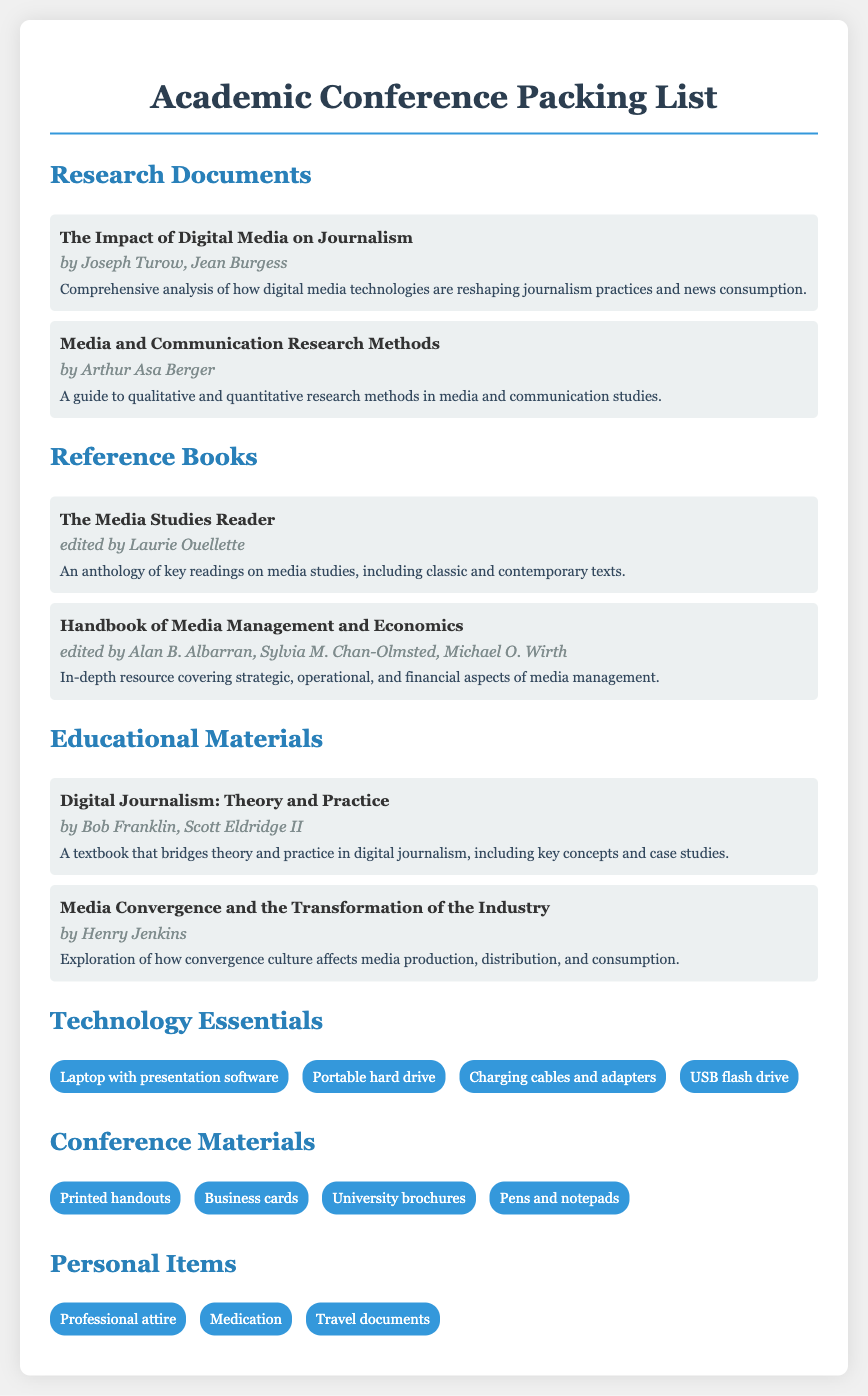What is the title of the first research document? The title of the first research document listed in the packing list is presented at the beginning of the respective section.
Answer: The Impact of Digital Media on Journalism Who authored "Media and Communication Research Methods"? The author is mentioned right after the title in the document, indicating who wrote the book.
Answer: Arthur Asa Berger How many reference books are listed? The total number is counted by reviewing the list under the Reference Books section.
Answer: 2 What is the main topic of "Digital Journalism: Theory and Practice"? The description provides key insights into the focus of the book, indicating it bridges theory and practice.
Answer: Theory and Practice Name one technology essential mentioned in the list. The specific items categorized under Technology Essentials are listed for retrieval.
Answer: Laptop with presentation software What type of personal items should be packed? The items categorized under Personal Items highlight necessary essentials that one should not forget.
Answer: Professional attire Which document is edited by Laurie Ouellette? By identifying the details in the Reference Books section, the editor is spelled out next to the title.
Answer: The Media Studies Reader What key theme is explored in "Media Convergence and the Transformation of the Industry"? This theme can be grasped from the description given in the Educational Materials section.
Answer: Convergence culture 